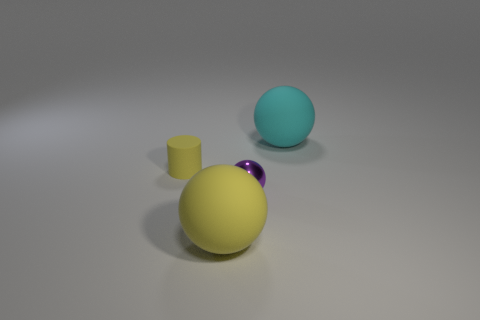Add 1 large yellow rubber spheres. How many objects exist? 5 Subtract all cylinders. How many objects are left? 3 Subtract all metallic things. Subtract all purple things. How many objects are left? 2 Add 4 big cyan matte objects. How many big cyan matte objects are left? 5 Add 3 small yellow metallic spheres. How many small yellow metallic spheres exist? 3 Subtract 0 green spheres. How many objects are left? 4 